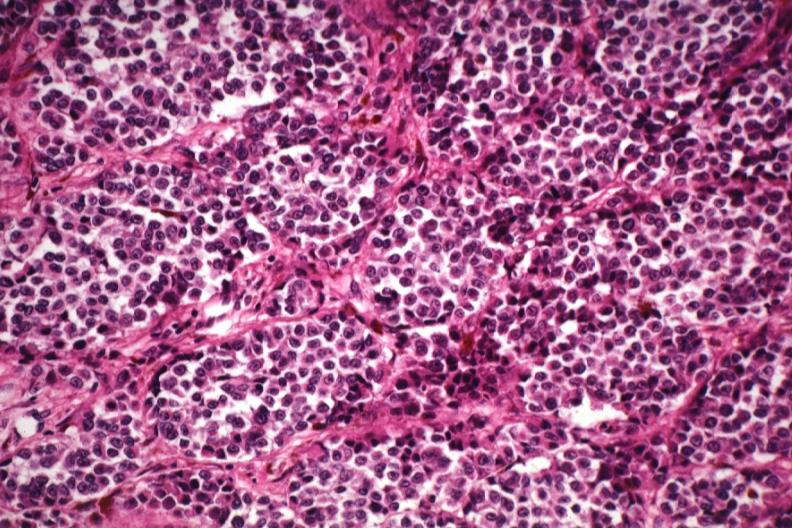what does this image show?
Answer the question using a single word or phrase. Good tumor cells with little pigment except in melanophores 